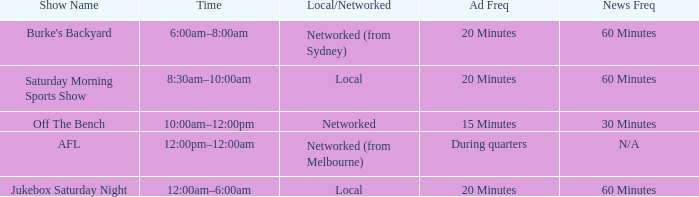What is the ad frequency for the Show Off The Bench? 15 Minutes. 